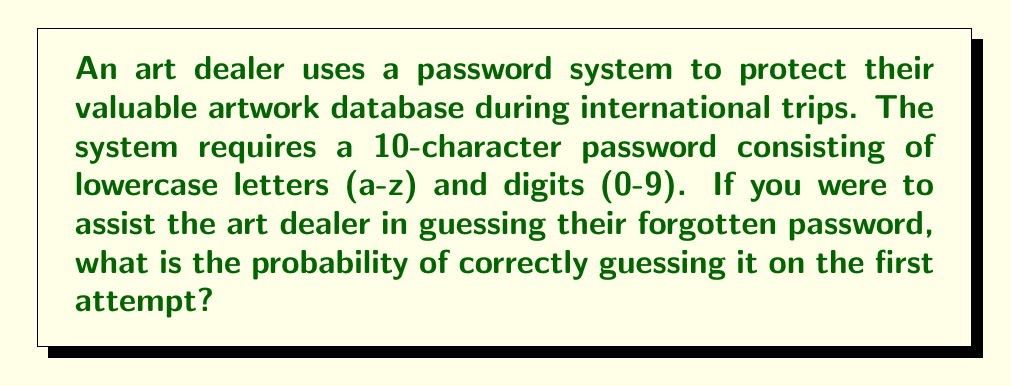What is the answer to this math problem? Let's approach this step-by-step:

1) First, we need to determine the total number of possible characters:
   - 26 lowercase letters (a-z)
   - 10 digits (0-9)
   Total: 26 + 10 = 36 possible characters

2) Now, for each character position in the password, there are 36 choices.

3) The password is 10 characters long, so we need to calculate the total number of possible passwords:
   
   $$ \text{Total possibilities} = 36^{10} $$

4) The probability of guessing correctly on the first attempt is 1 divided by the total number of possibilities:

   $$ P(\text{correct guess}) = \frac{1}{36^{10}} $$

5) Let's calculate this:
   
   $$ P(\text{correct guess}) = \frac{1}{36^{10}} \approx 2.75 \times 10^{-16} $$

This extremely small probability demonstrates the strength of using a long password with a diverse character set, which is crucial for protecting valuable art information during international travels.
Answer: $\frac{1}{36^{10}} \approx 2.75 \times 10^{-16}$ 